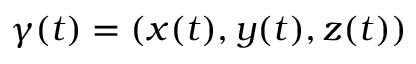<formula> <loc_0><loc_0><loc_500><loc_500>\gamma ( t ) = ( x ( t ) , y ( t ) , z ( t ) )</formula> 